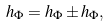Convert formula to latex. <formula><loc_0><loc_0><loc_500><loc_500>h _ { \Phi } = h _ { \Phi } \pm h _ { \Phi } ,</formula> 